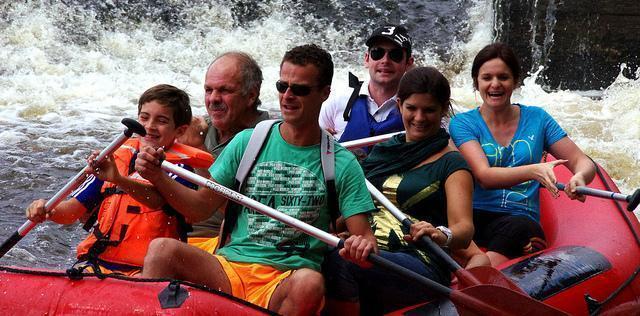What safety item is the person in Green and blue shirts missing?
Select the accurate response from the four choices given to answer the question.
Options: Life vest, bear spray, oar, whistle. Life vest. 